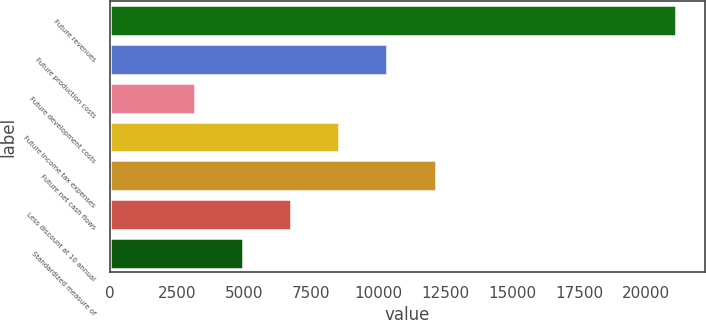Convert chart to OTSL. <chart><loc_0><loc_0><loc_500><loc_500><bar_chart><fcel>Future revenues<fcel>Future production costs<fcel>Future development costs<fcel>Future income tax expenses<fcel>Future net cash flows<fcel>Less discount at 10 annual<fcel>Standardized measure of<nl><fcel>21112<fcel>10351.6<fcel>3178<fcel>8558.2<fcel>12145<fcel>6764.8<fcel>4971.4<nl></chart> 